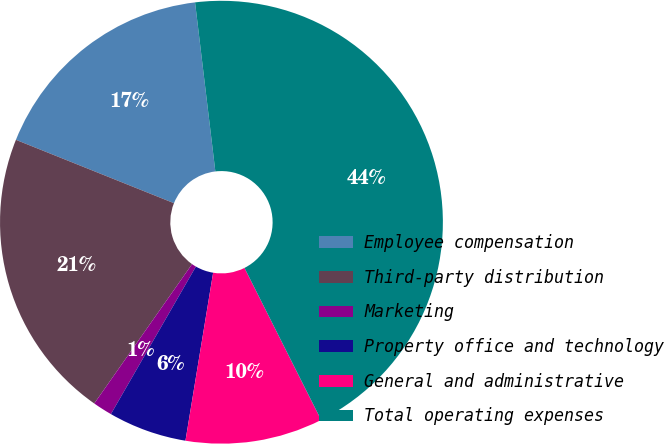Convert chart. <chart><loc_0><loc_0><loc_500><loc_500><pie_chart><fcel>Employee compensation<fcel>Third-party distribution<fcel>Marketing<fcel>Property office and technology<fcel>General and administrative<fcel>Total operating expenses<nl><fcel>17.03%<fcel>21.33%<fcel>1.42%<fcel>5.72%<fcel>10.03%<fcel>44.47%<nl></chart> 